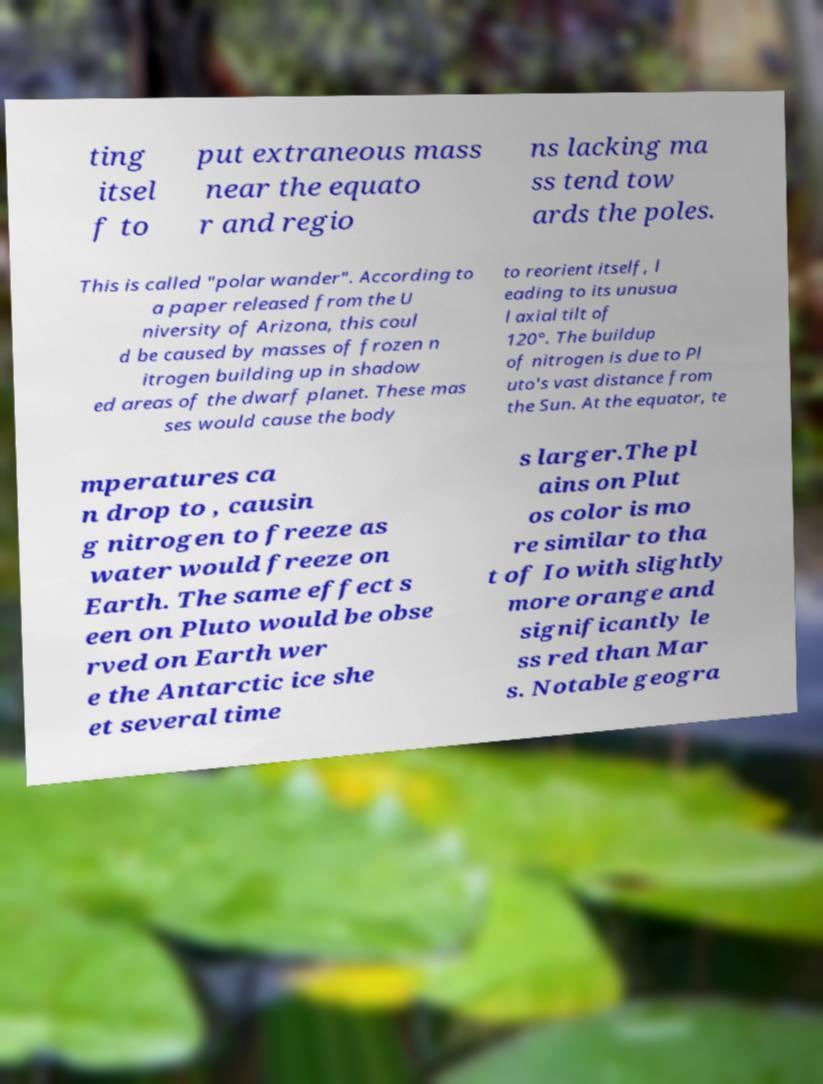What messages or text are displayed in this image? I need them in a readable, typed format. ting itsel f to put extraneous mass near the equato r and regio ns lacking ma ss tend tow ards the poles. This is called "polar wander". According to a paper released from the U niversity of Arizona, this coul d be caused by masses of frozen n itrogen building up in shadow ed areas of the dwarf planet. These mas ses would cause the body to reorient itself, l eading to its unusua l axial tilt of 120°. The buildup of nitrogen is due to Pl uto's vast distance from the Sun. At the equator, te mperatures ca n drop to , causin g nitrogen to freeze as water would freeze on Earth. The same effect s een on Pluto would be obse rved on Earth wer e the Antarctic ice she et several time s larger.The pl ains on Plut os color is mo re similar to tha t of Io with slightly more orange and significantly le ss red than Mar s. Notable geogra 